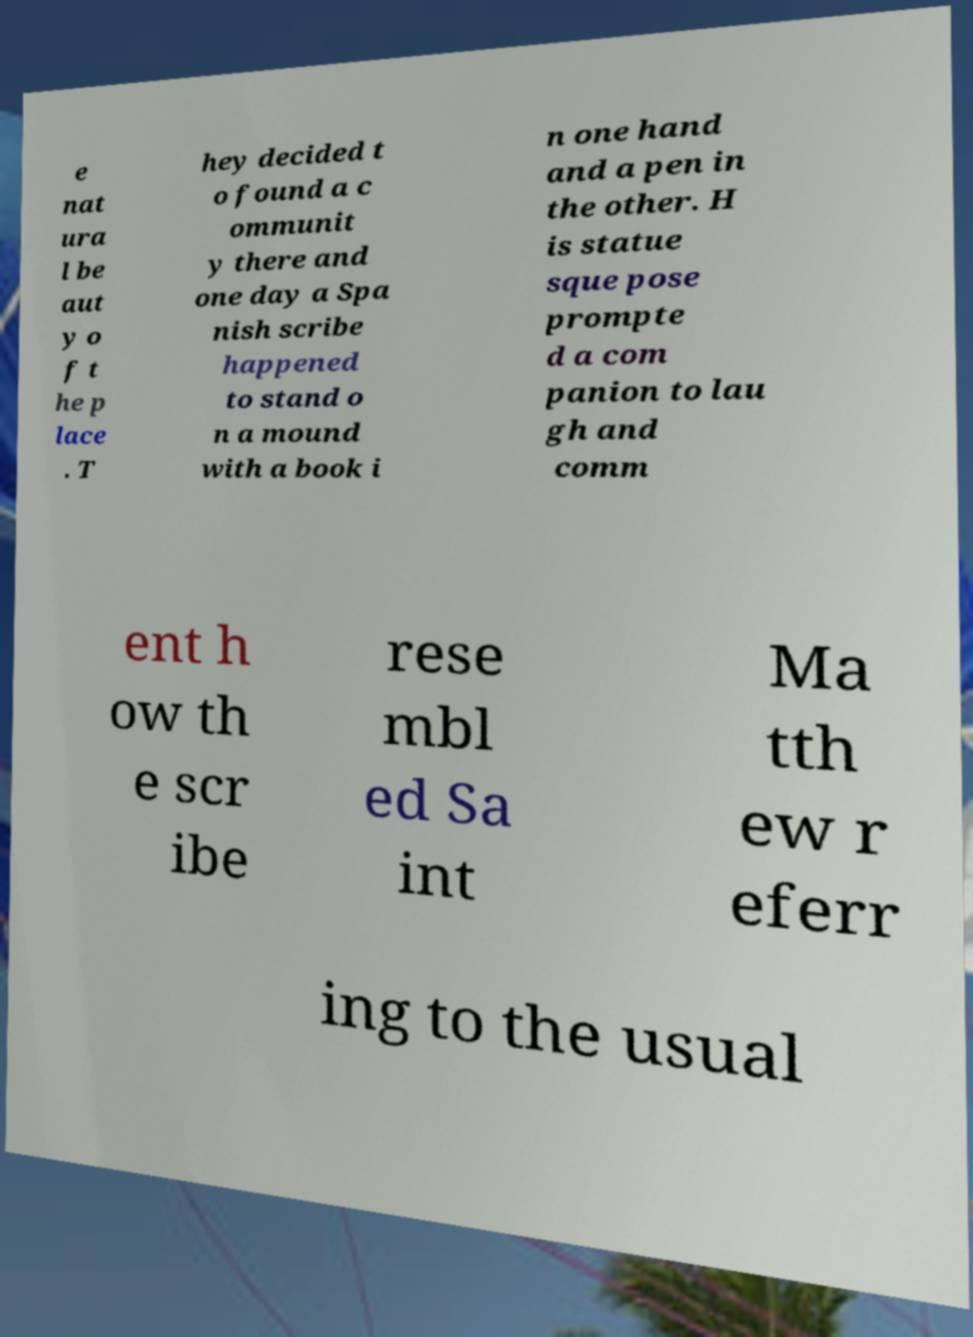Can you read and provide the text displayed in the image?This photo seems to have some interesting text. Can you extract and type it out for me? e nat ura l be aut y o f t he p lace . T hey decided t o found a c ommunit y there and one day a Spa nish scribe happened to stand o n a mound with a book i n one hand and a pen in the other. H is statue sque pose prompte d a com panion to lau gh and comm ent h ow th e scr ibe rese mbl ed Sa int Ma tth ew r eferr ing to the usual 